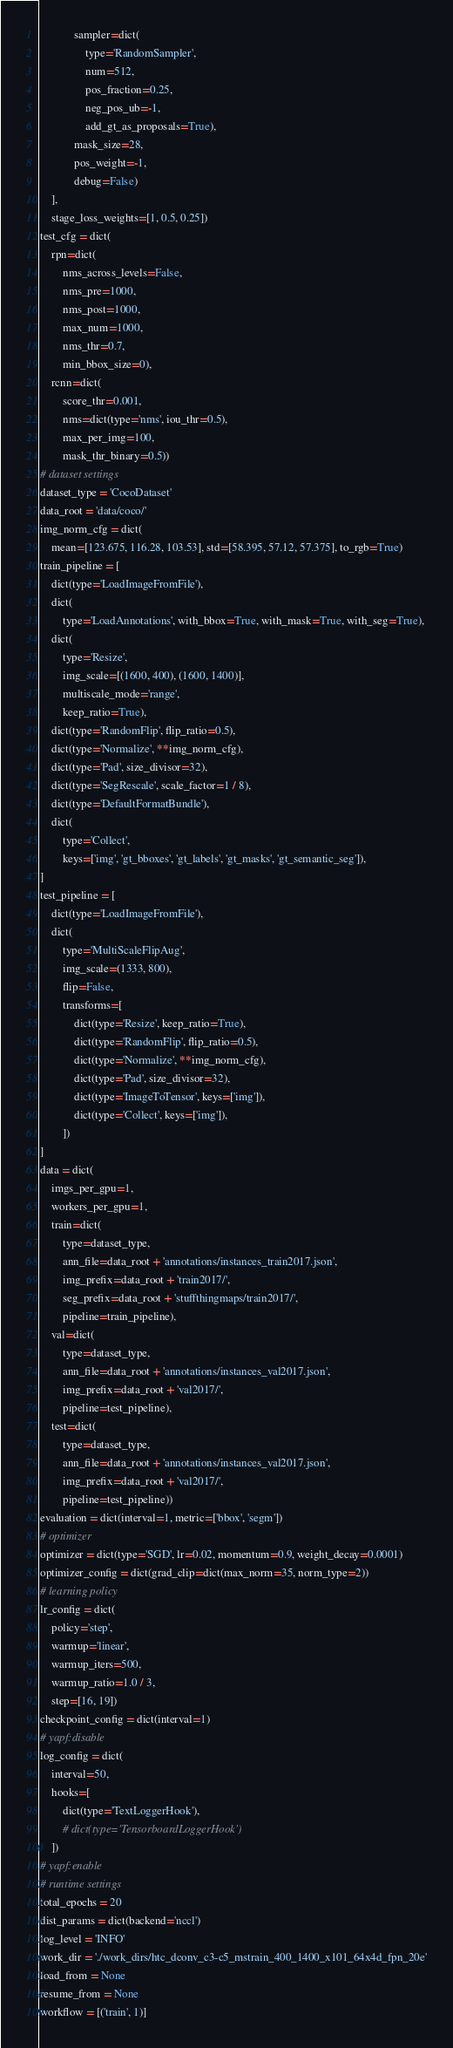Convert code to text. <code><loc_0><loc_0><loc_500><loc_500><_Python_>            sampler=dict(
                type='RandomSampler',
                num=512,
                pos_fraction=0.25,
                neg_pos_ub=-1,
                add_gt_as_proposals=True),
            mask_size=28,
            pos_weight=-1,
            debug=False)
    ],
    stage_loss_weights=[1, 0.5, 0.25])
test_cfg = dict(
    rpn=dict(
        nms_across_levels=False,
        nms_pre=1000,
        nms_post=1000,
        max_num=1000,
        nms_thr=0.7,
        min_bbox_size=0),
    rcnn=dict(
        score_thr=0.001,
        nms=dict(type='nms', iou_thr=0.5),
        max_per_img=100,
        mask_thr_binary=0.5))
# dataset settings
dataset_type = 'CocoDataset'
data_root = 'data/coco/'
img_norm_cfg = dict(
    mean=[123.675, 116.28, 103.53], std=[58.395, 57.12, 57.375], to_rgb=True)
train_pipeline = [
    dict(type='LoadImageFromFile'),
    dict(
        type='LoadAnnotations', with_bbox=True, with_mask=True, with_seg=True),
    dict(
        type='Resize',
        img_scale=[(1600, 400), (1600, 1400)],
        multiscale_mode='range',
        keep_ratio=True),
    dict(type='RandomFlip', flip_ratio=0.5),
    dict(type='Normalize', **img_norm_cfg),
    dict(type='Pad', size_divisor=32),
    dict(type='SegRescale', scale_factor=1 / 8),
    dict(type='DefaultFormatBundle'),
    dict(
        type='Collect',
        keys=['img', 'gt_bboxes', 'gt_labels', 'gt_masks', 'gt_semantic_seg']),
]
test_pipeline = [
    dict(type='LoadImageFromFile'),
    dict(
        type='MultiScaleFlipAug',
        img_scale=(1333, 800),
        flip=False,
        transforms=[
            dict(type='Resize', keep_ratio=True),
            dict(type='RandomFlip', flip_ratio=0.5),
            dict(type='Normalize', **img_norm_cfg),
            dict(type='Pad', size_divisor=32),
            dict(type='ImageToTensor', keys=['img']),
            dict(type='Collect', keys=['img']),
        ])
]
data = dict(
    imgs_per_gpu=1,
    workers_per_gpu=1,
    train=dict(
        type=dataset_type,
        ann_file=data_root + 'annotations/instances_train2017.json',
        img_prefix=data_root + 'train2017/',
        seg_prefix=data_root + 'stuffthingmaps/train2017/',
        pipeline=train_pipeline),
    val=dict(
        type=dataset_type,
        ann_file=data_root + 'annotations/instances_val2017.json',
        img_prefix=data_root + 'val2017/',
        pipeline=test_pipeline),
    test=dict(
        type=dataset_type,
        ann_file=data_root + 'annotations/instances_val2017.json',
        img_prefix=data_root + 'val2017/',
        pipeline=test_pipeline))
evaluation = dict(interval=1, metric=['bbox', 'segm'])
# optimizer
optimizer = dict(type='SGD', lr=0.02, momentum=0.9, weight_decay=0.0001)
optimizer_config = dict(grad_clip=dict(max_norm=35, norm_type=2))
# learning policy
lr_config = dict(
    policy='step',
    warmup='linear',
    warmup_iters=500,
    warmup_ratio=1.0 / 3,
    step=[16, 19])
checkpoint_config = dict(interval=1)
# yapf:disable
log_config = dict(
    interval=50,
    hooks=[
        dict(type='TextLoggerHook'),
        # dict(type='TensorboardLoggerHook')
    ])
# yapf:enable
# runtime settings
total_epochs = 20
dist_params = dict(backend='nccl')
log_level = 'INFO'
work_dir = './work_dirs/htc_dconv_c3-c5_mstrain_400_1400_x101_64x4d_fpn_20e'
load_from = None
resume_from = None
workflow = [('train', 1)]
</code> 